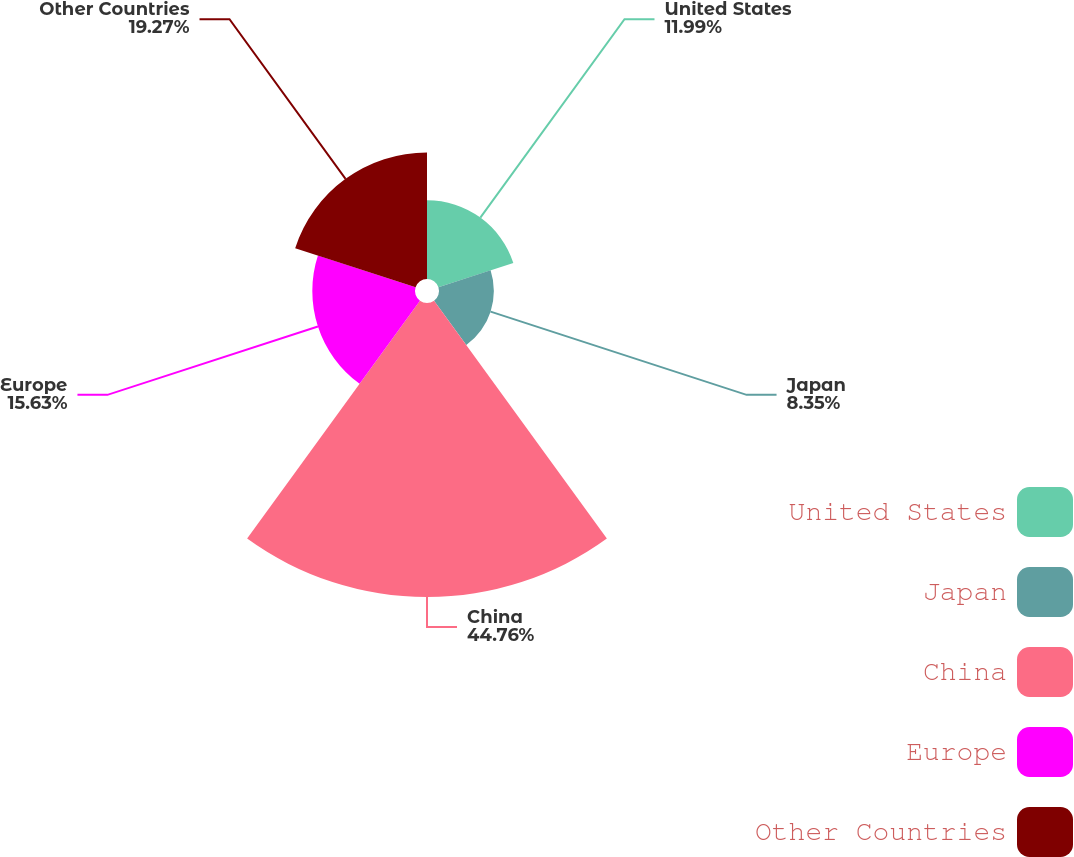<chart> <loc_0><loc_0><loc_500><loc_500><pie_chart><fcel>United States<fcel>Japan<fcel>China<fcel>Europe<fcel>Other Countries<nl><fcel>11.99%<fcel>8.35%<fcel>44.75%<fcel>15.63%<fcel>19.27%<nl></chart> 